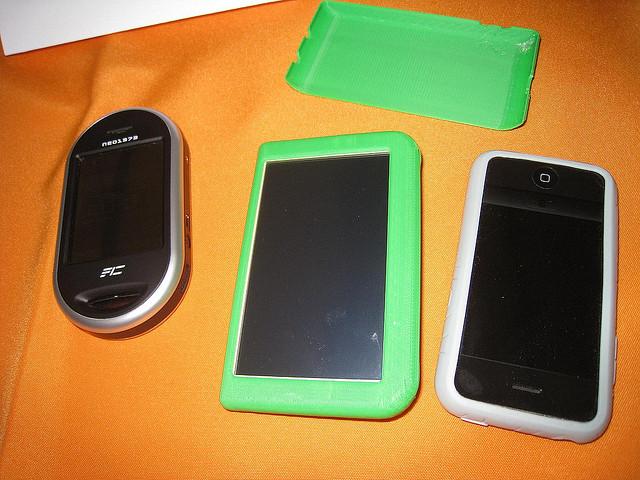What color is the phone in the middle?
Be succinct. Green. What color is the tablecloth?
Quick response, please. Orange. Are these phones?
Keep it brief. Yes. 